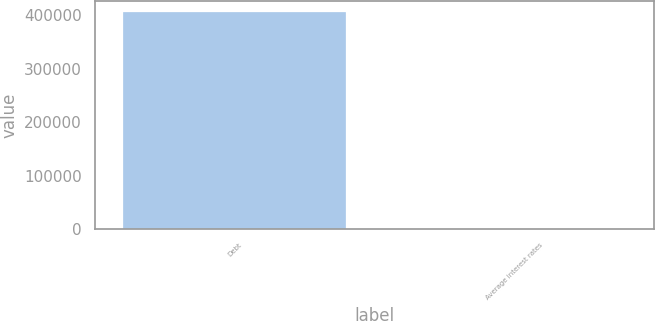Convert chart to OTSL. <chart><loc_0><loc_0><loc_500><loc_500><bar_chart><fcel>Debt<fcel>Average interest rates<nl><fcel>405613<fcel>3.7<nl></chart> 